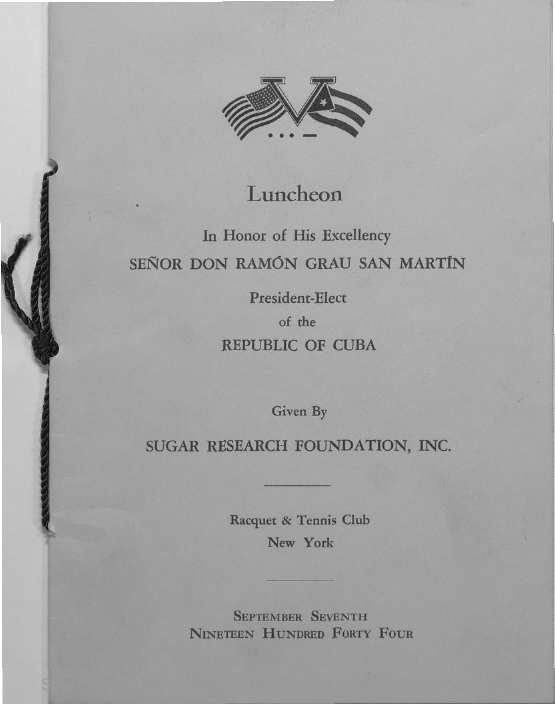Draw attention to some important aspects in this diagram. The date of luncheon is September 7th, 1944. Senor Don Ramon Grau San Martin belongs to the Republic of Cuba. 